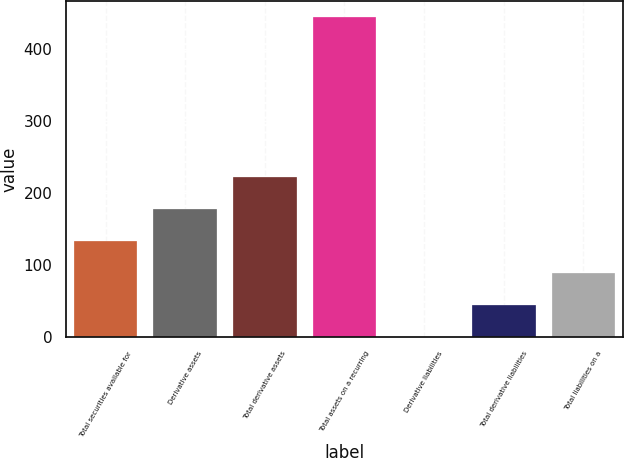Convert chart. <chart><loc_0><loc_0><loc_500><loc_500><bar_chart><fcel>Total securities available for<fcel>Derivative assets<fcel>Total derivative assets<fcel>Total assets on a recurring<fcel>Derivative liabilities<fcel>Total derivative liabilities<fcel>Total liabilities on a<nl><fcel>133.9<fcel>178.2<fcel>222.5<fcel>444<fcel>1<fcel>45.3<fcel>89.6<nl></chart> 